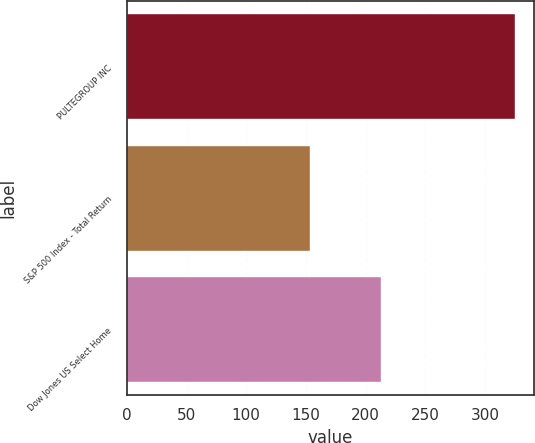<chart> <loc_0><loc_0><loc_500><loc_500><bar_chart><fcel>PULTEGROUP INC<fcel>S&P 500 Index - Total Return<fcel>Dow Jones US Select Home<nl><fcel>325.2<fcel>153.57<fcel>212.75<nl></chart> 